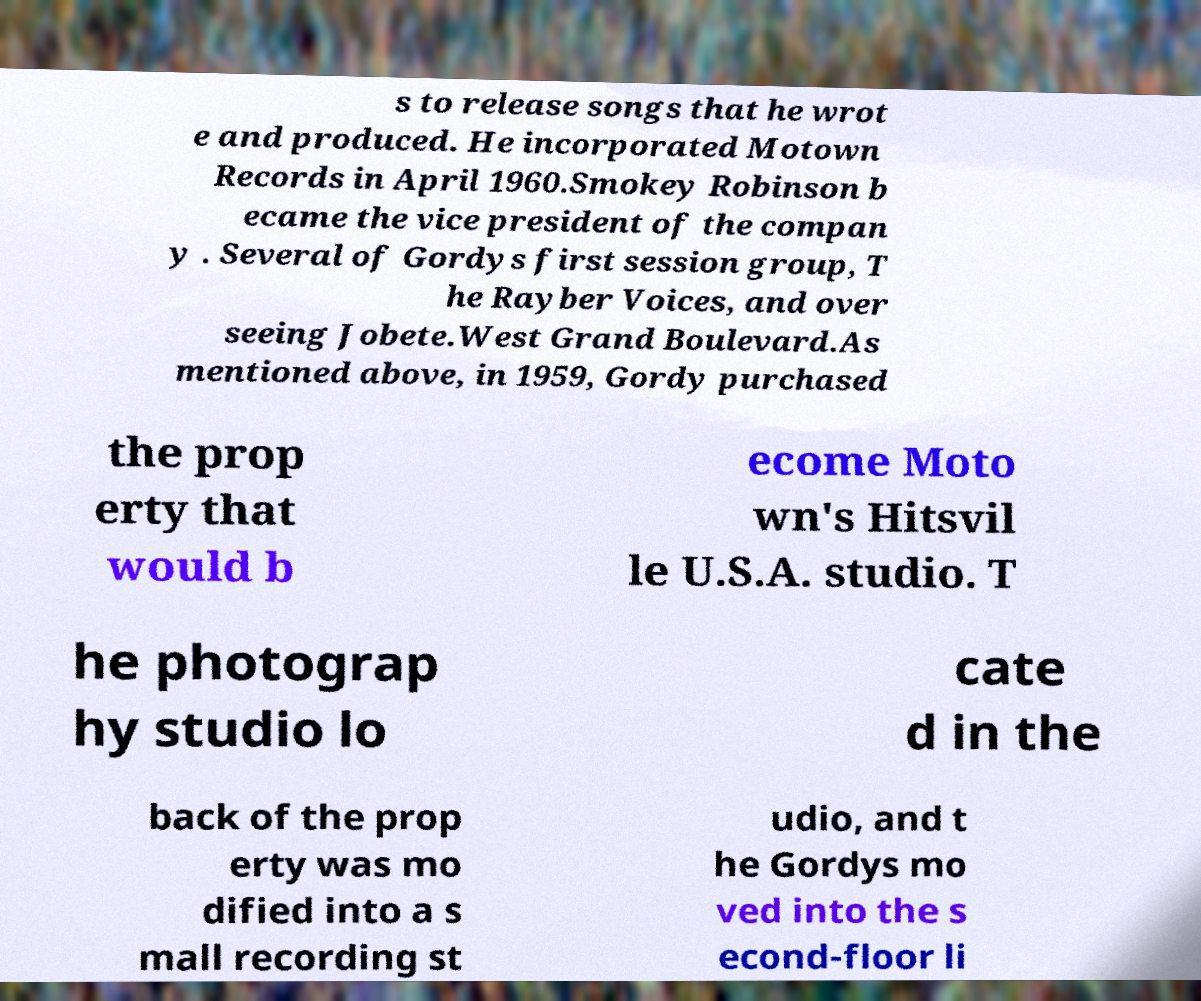There's text embedded in this image that I need extracted. Can you transcribe it verbatim? s to release songs that he wrot e and produced. He incorporated Motown Records in April 1960.Smokey Robinson b ecame the vice president of the compan y . Several of Gordys first session group, T he Rayber Voices, and over seeing Jobete.West Grand Boulevard.As mentioned above, in 1959, Gordy purchased the prop erty that would b ecome Moto wn's Hitsvil le U.S.A. studio. T he photograp hy studio lo cate d in the back of the prop erty was mo dified into a s mall recording st udio, and t he Gordys mo ved into the s econd-floor li 